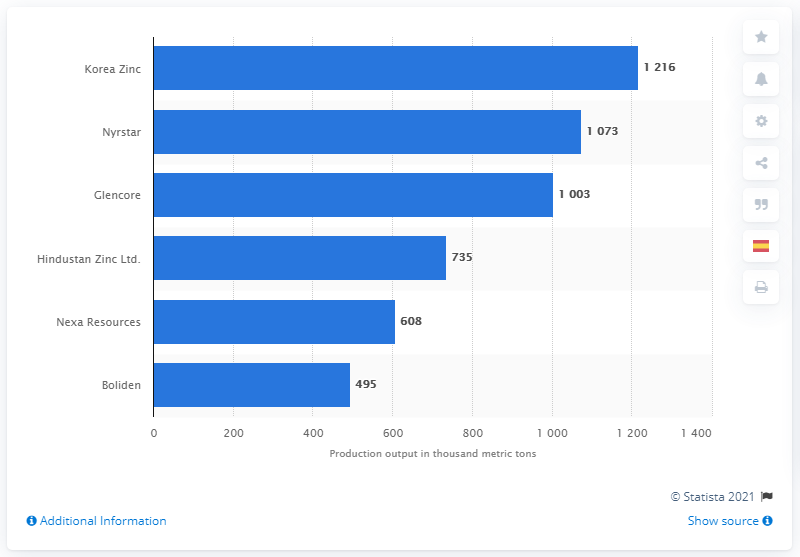Specify some key components in this picture. Korea Zinc was the number one smelter of zinc in 2018, according to sources. 